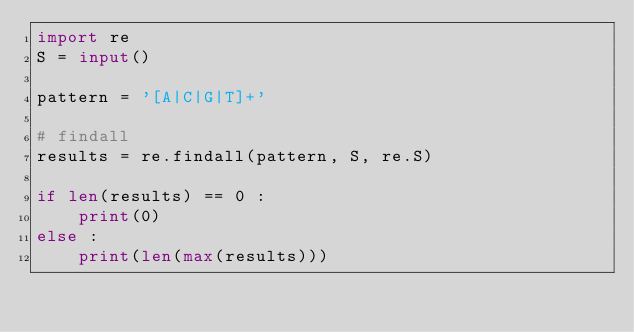Convert code to text. <code><loc_0><loc_0><loc_500><loc_500><_Python_>import re
S = input()

pattern = '[A|C|G|T]+'

# findall 
results = re.findall(pattern, S, re.S)

if len(results) == 0 :
    print(0)
else :
    print(len(max(results)))</code> 